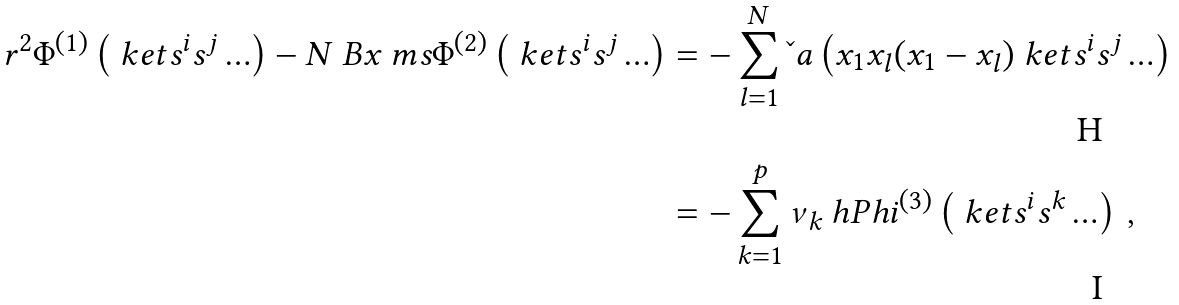<formula> <loc_0><loc_0><loc_500><loc_500>r ^ { 2 } \Phi ^ { ( 1 ) } \left ( \ k e t { s ^ { i } s ^ { j } \dots } \right ) - N \ B x \ m s \Phi ^ { ( 2 ) } \left ( \ k e t { s ^ { i } s ^ { j } \dots } \right ) & = - \sum _ { l = 1 } ^ { N } \L a \left ( x _ { 1 } x _ { l } ( x _ { 1 } - x _ { l } ) \ k e t { s ^ { i } s ^ { j } \dots } \right ) \\ & = - \sum _ { k = 1 } ^ { p } \nu _ { k } \ h P h i ^ { ( 3 ) } \left ( \ k e t { s ^ { i } s ^ { k } \dots } \right ) \, ,</formula> 